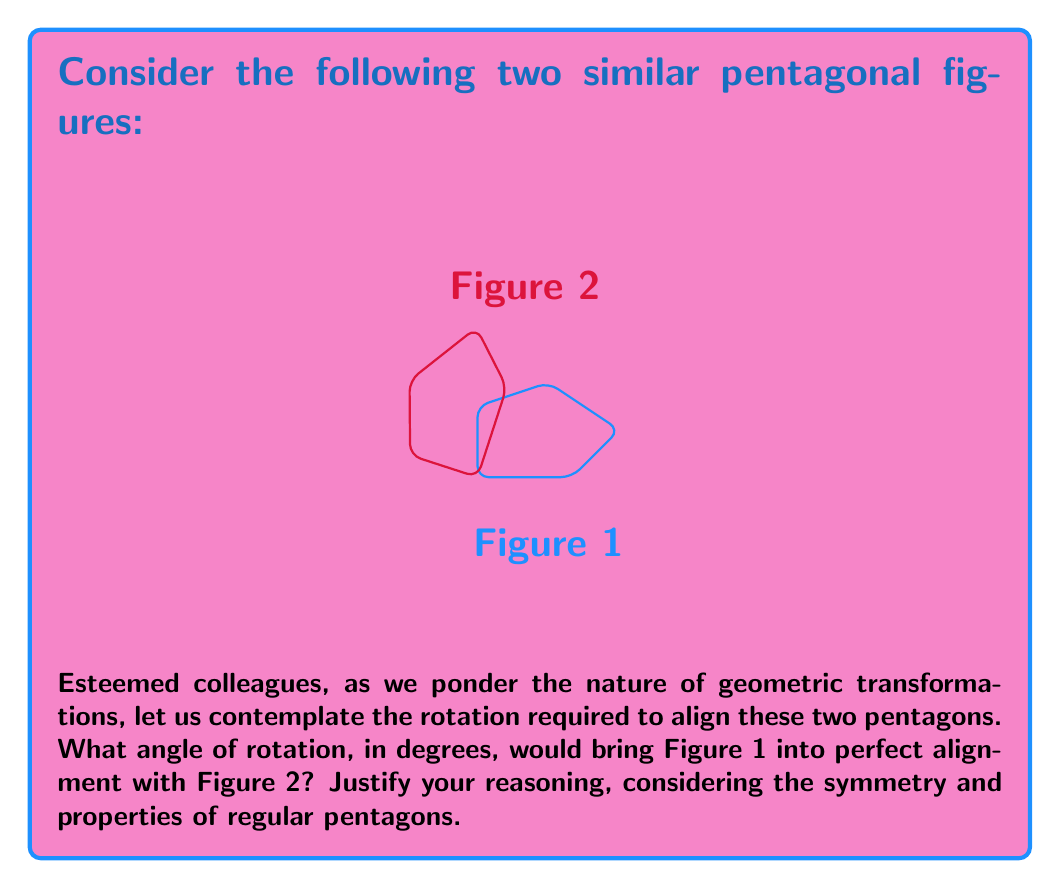Can you answer this question? Let us approach this problem step-by-step, employing both geometric reasoning and mathematical precision:

1) First, we must recognize that these pentagons appear to be regular. A regular pentagon has five-fold rotational symmetry, meaning it can be rotated by multiples of 72° (360° ÷ 5) to align with itself.

2) The rotation from Figure 1 to Figure 2 appears to be clockwise. In mathematics, we typically consider counterclockwise rotations as positive, so we'll need to determine the equivalent counterclockwise rotation.

3) Observing the figures, we can see that Figure 2 seems to be rotated by one-fifth of a full rotation relative to Figure 1. This corresponds to a 72° clockwise rotation.

4) To express this as a counterclockwise rotation, we can subtract 72° from 360°:

   $$ 360° - 72° = 288° $$

5) We can verify this by considering the properties of regular pentagons:
   - The internal angle of a regular pentagon is $(540° / 5) = 108°$
   - The external angle (supplement of the internal angle) is $180° - 108° = 72°$

6) Therefore, a rotation of 288° counterclockwise (or 72° clockwise) would indeed bring Figure 1 into alignment with Figure 2.

This geometric transformation exemplifies the profound connection between symmetry and rotational properties in regular polygons, a concept that extends far beyond mere visual alignment into the realms of group theory and abstract algebra.
Answer: 288° 